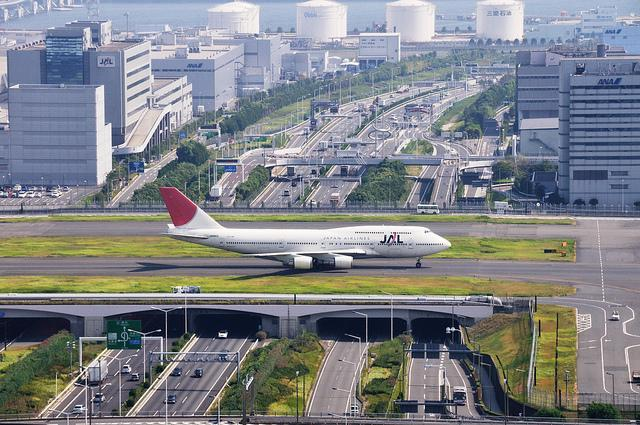What is the large vehicle getting ready to do? fly 